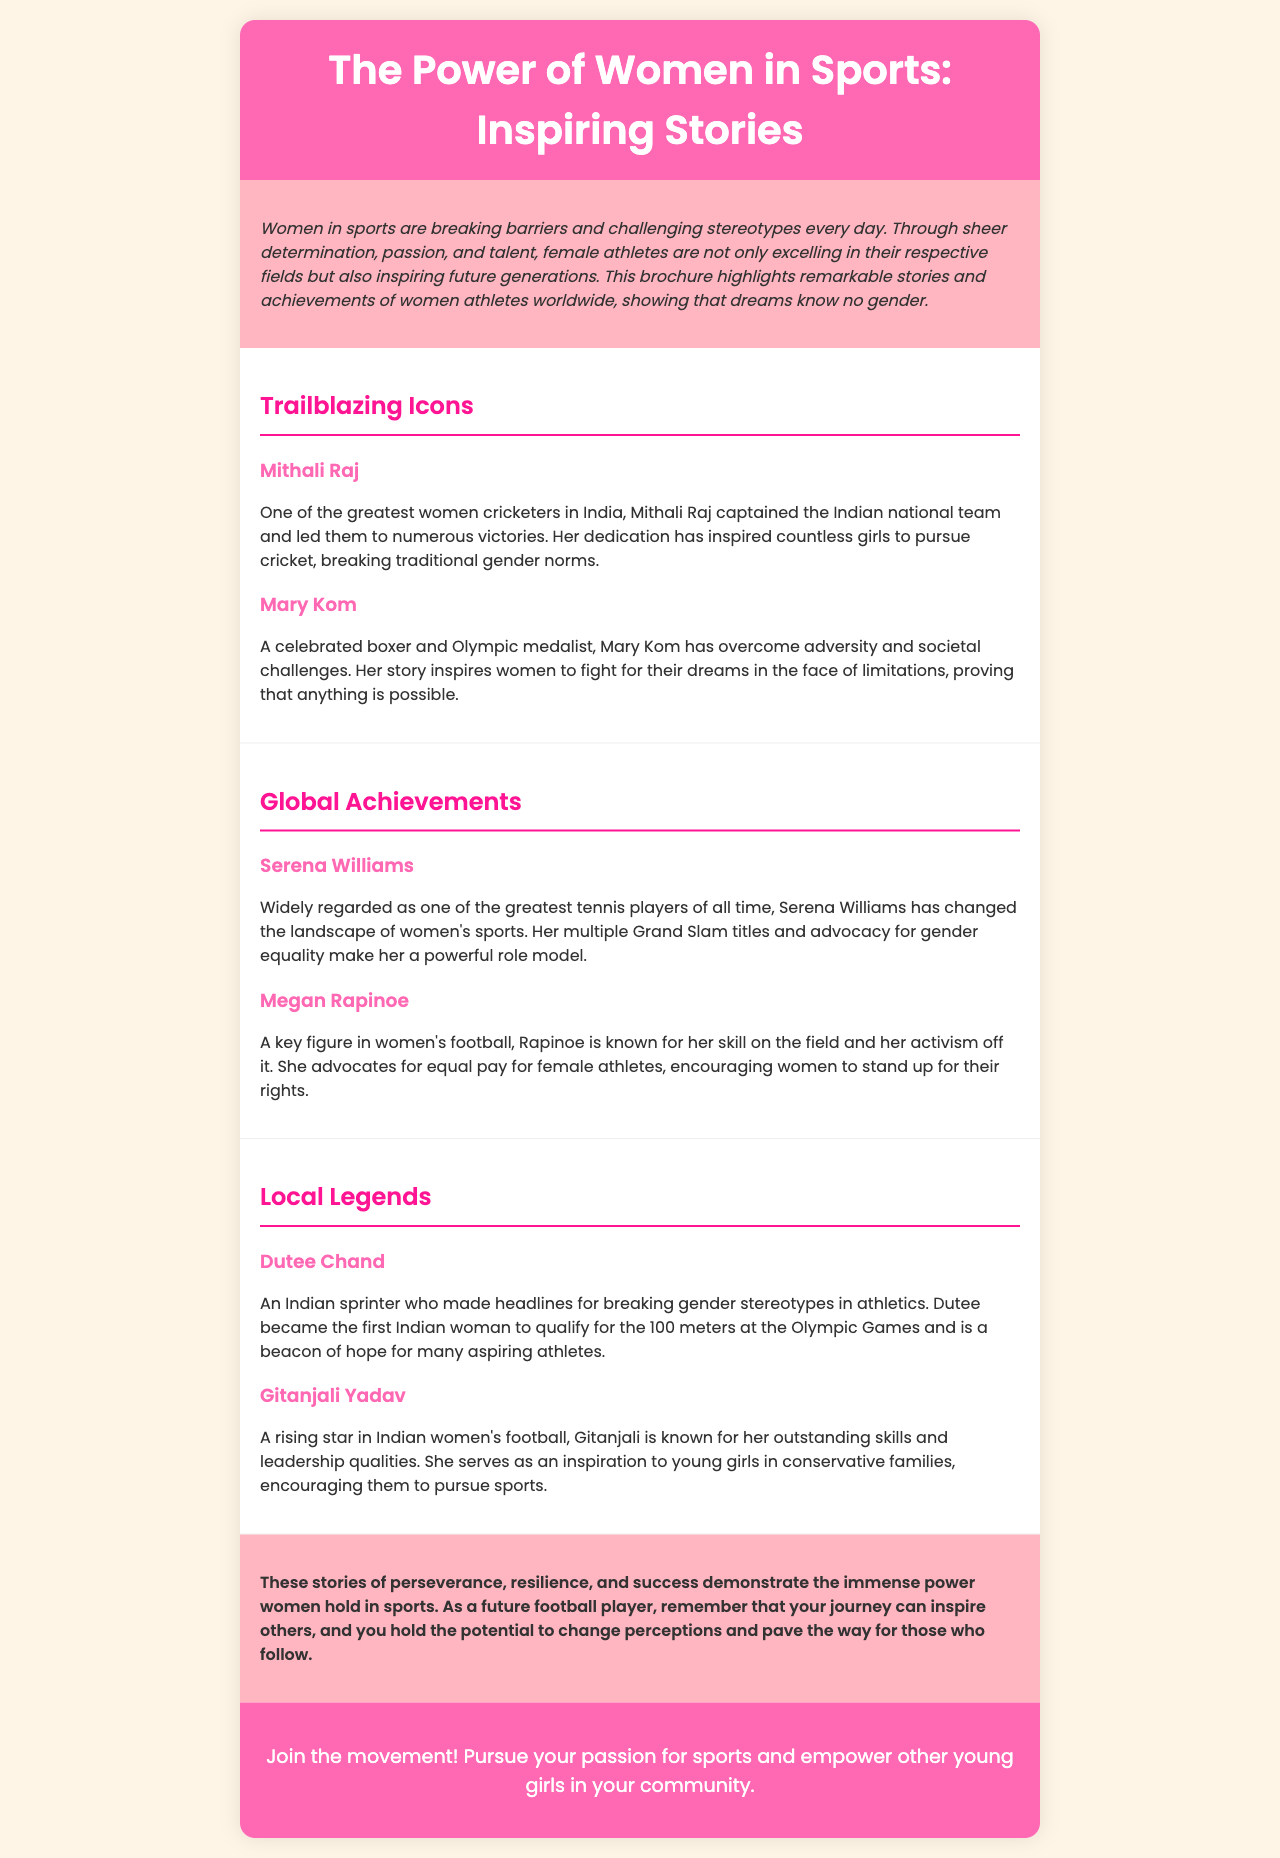what is the title of the brochure? The title of the brochure is found in the header section, which introduces the main topic and theme.
Answer: The Power of Women in Sports: Inspiring Stories who is one of the greatest women cricketers in India mentioned in the brochure? The brochure lists Mithali Raj as one of the greatest women cricketers in India in the "Trailblazing Icons" section.
Answer: Mithali Raj what is Dutee Chand known for? The brochure notes that Dutee Chand is known for breaking gender stereotypes in athletics and qualifying for the Olympics.
Answer: Breaking gender stereotypes how many Grand Slam titles does Serena Williams have? The brochure describes Serena Williams as widely regarded as one of the greatest tennis players but does not specify the number of Grand Slam titles.
Answer: Not specified which athlete advocates for equal pay for female athletes? In the document, Megan Rapinoe is identified as advocating for equal pay for female athletes.
Answer: Megan Rapinoe what is the color of the brochure's header section? The header section of the brochure is designed with a specific background color that highlights the title and catches attention.
Answer: Pink who is a rising star in Indian women's football mentioned in the brochure? Gitanjali Yadav is introduced as a rising star in Indian women's football in the "Local Legends" section.
Answer: Gitanjali Yadav what is the main message of the brochure? The brochure emphasizes the empowerment of women in sports and the importance of inspiring others to pursue their dreams.
Answer: Empowering women in sports how does the brochure suggest young girls in conservative families should feel? The brochure aims to inspire young girls in conservative families by showcasing the achievements of female athletes and encouraging them to pursue sports.
Answer: Inspired to pursue sports 